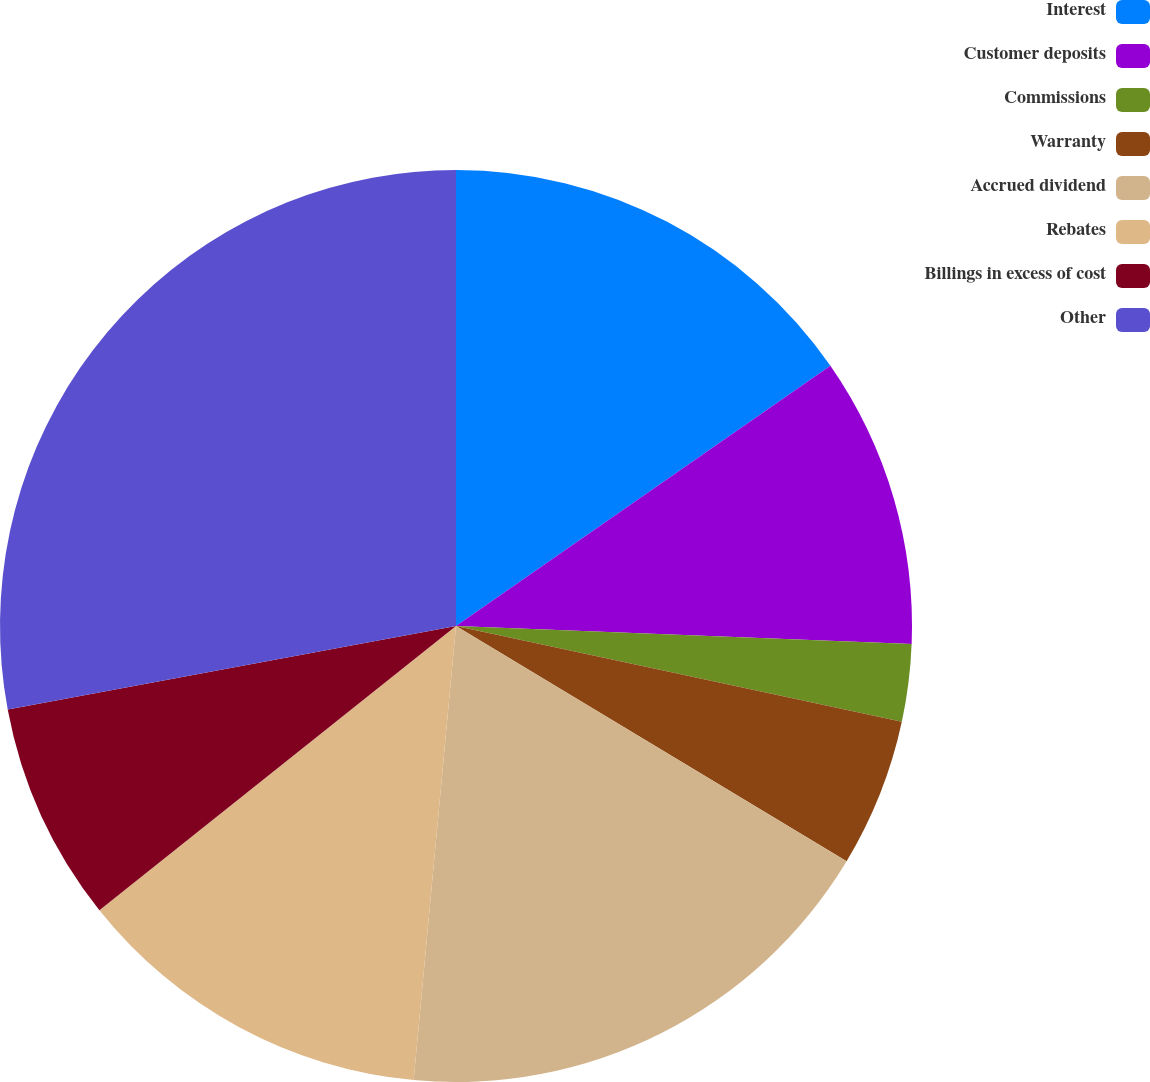Convert chart to OTSL. <chart><loc_0><loc_0><loc_500><loc_500><pie_chart><fcel>Interest<fcel>Customer deposits<fcel>Commissions<fcel>Warranty<fcel>Accrued dividend<fcel>Rebates<fcel>Billings in excess of cost<fcel>Other<nl><fcel>15.33%<fcel>10.3%<fcel>2.74%<fcel>5.26%<fcel>17.85%<fcel>12.81%<fcel>7.78%<fcel>27.93%<nl></chart> 